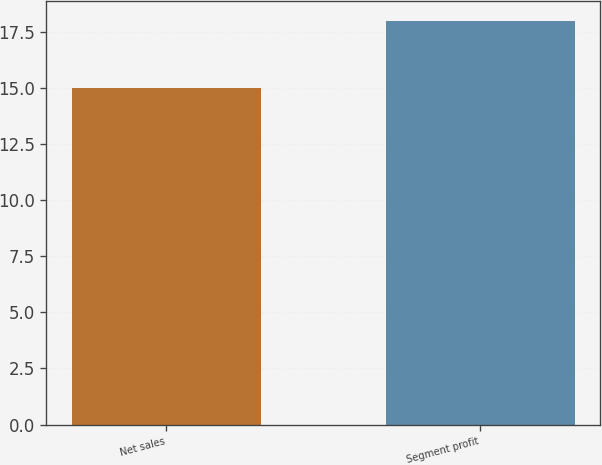<chart> <loc_0><loc_0><loc_500><loc_500><bar_chart><fcel>Net sales<fcel>Segment profit<nl><fcel>15<fcel>18<nl></chart> 